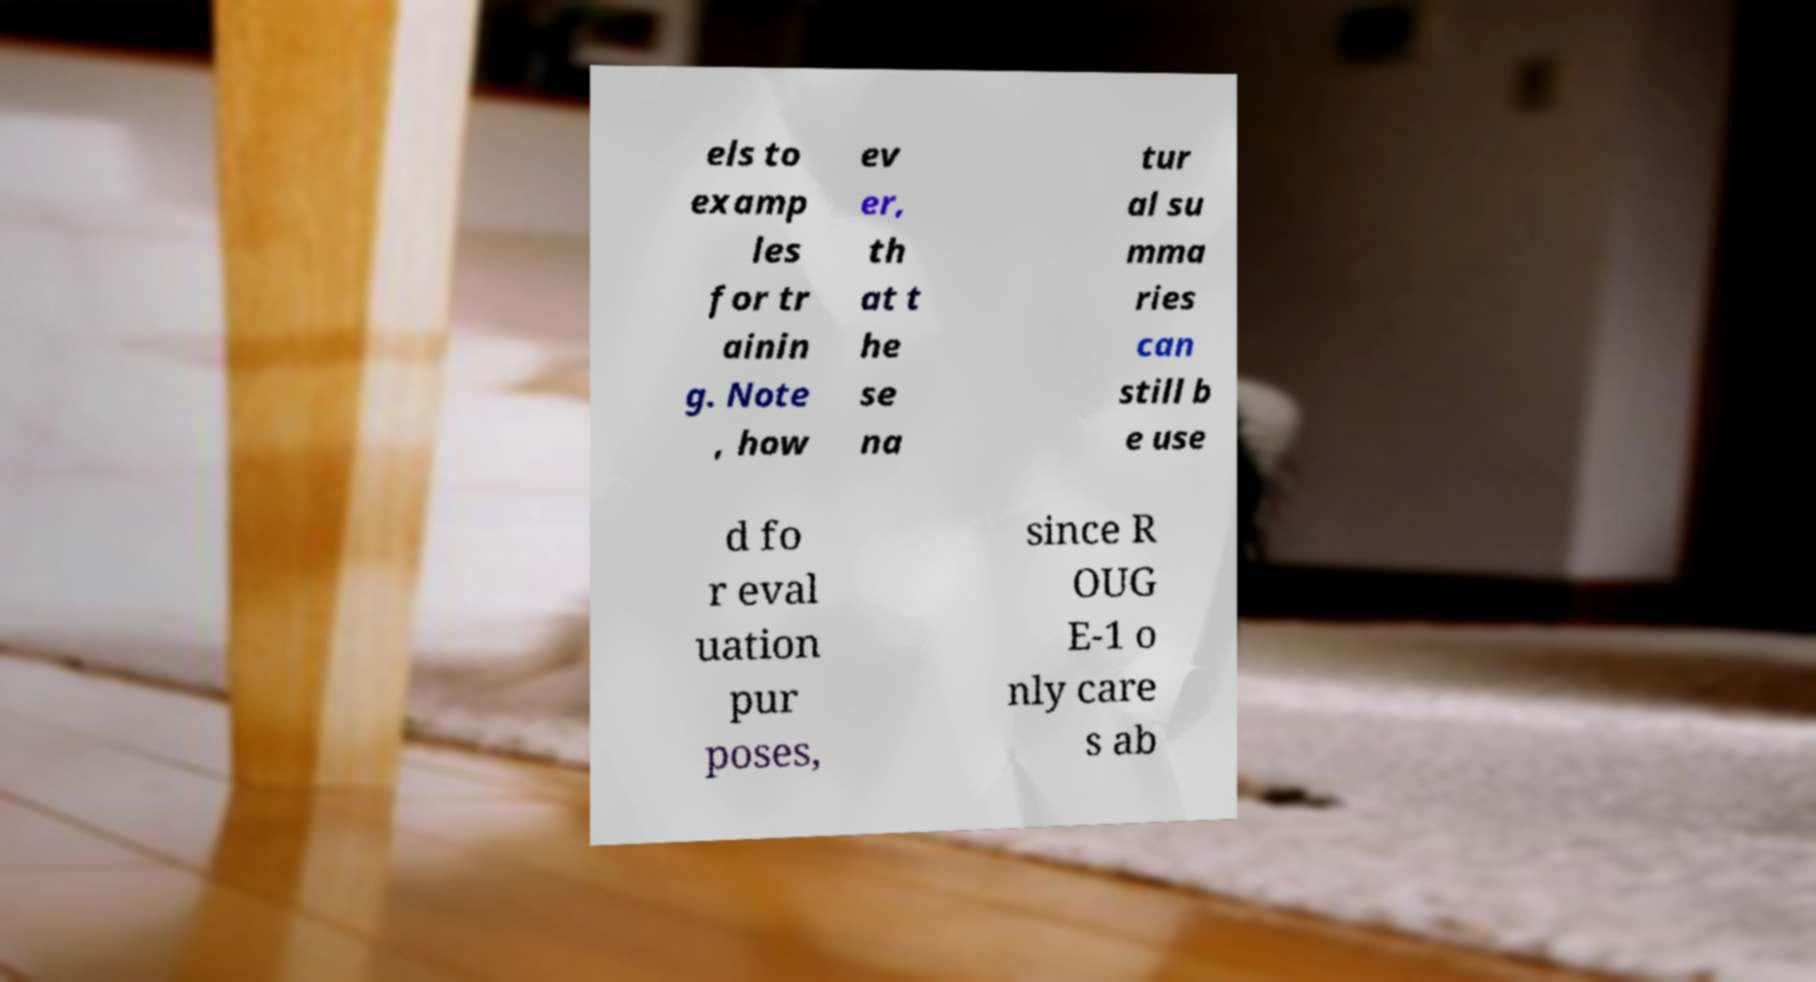Can you accurately transcribe the text from the provided image for me? els to examp les for tr ainin g. Note , how ev er, th at t he se na tur al su mma ries can still b e use d fo r eval uation pur poses, since R OUG E-1 o nly care s ab 